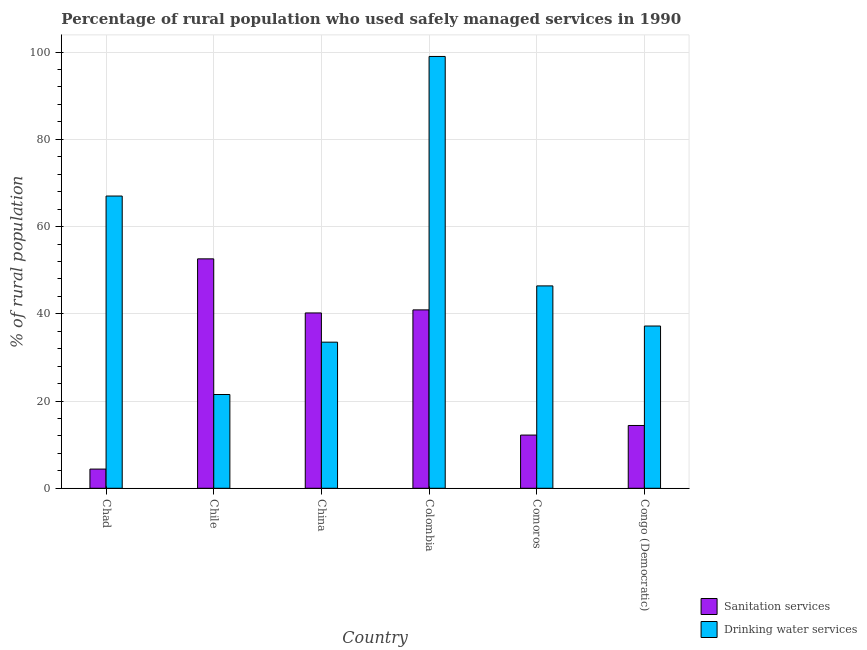How many bars are there on the 5th tick from the left?
Your response must be concise. 2. What is the label of the 2nd group of bars from the left?
Keep it short and to the point. Chile. What is the percentage of rural population who used drinking water services in Comoros?
Make the answer very short. 46.4. Across all countries, what is the maximum percentage of rural population who used sanitation services?
Your answer should be compact. 52.6. Across all countries, what is the minimum percentage of rural population who used sanitation services?
Offer a terse response. 4.4. In which country was the percentage of rural population who used sanitation services minimum?
Keep it short and to the point. Chad. What is the total percentage of rural population who used sanitation services in the graph?
Keep it short and to the point. 164.7. What is the difference between the percentage of rural population who used sanitation services in Chile and that in Congo (Democratic)?
Your answer should be very brief. 38.2. What is the difference between the percentage of rural population who used sanitation services in Chad and the percentage of rural population who used drinking water services in Chile?
Make the answer very short. -17.1. What is the average percentage of rural population who used sanitation services per country?
Make the answer very short. 27.45. What is the difference between the percentage of rural population who used sanitation services and percentage of rural population who used drinking water services in Congo (Democratic)?
Your answer should be compact. -22.8. In how many countries, is the percentage of rural population who used sanitation services greater than 12 %?
Your response must be concise. 5. What is the ratio of the percentage of rural population who used drinking water services in Chad to that in Colombia?
Provide a succinct answer. 0.68. Is the percentage of rural population who used sanitation services in China less than that in Congo (Democratic)?
Provide a short and direct response. No. Is the difference between the percentage of rural population who used drinking water services in Chad and Comoros greater than the difference between the percentage of rural population who used sanitation services in Chad and Comoros?
Offer a terse response. Yes. What is the difference between the highest and the second highest percentage of rural population who used drinking water services?
Offer a terse response. 32. What is the difference between the highest and the lowest percentage of rural population who used drinking water services?
Provide a succinct answer. 77.5. Is the sum of the percentage of rural population who used sanitation services in Chile and Colombia greater than the maximum percentage of rural population who used drinking water services across all countries?
Make the answer very short. No. What does the 2nd bar from the left in Colombia represents?
Keep it short and to the point. Drinking water services. What does the 1st bar from the right in Chile represents?
Offer a terse response. Drinking water services. Are all the bars in the graph horizontal?
Offer a very short reply. No. Does the graph contain any zero values?
Offer a very short reply. No. Where does the legend appear in the graph?
Offer a very short reply. Bottom right. What is the title of the graph?
Your response must be concise. Percentage of rural population who used safely managed services in 1990. What is the label or title of the X-axis?
Provide a succinct answer. Country. What is the label or title of the Y-axis?
Offer a very short reply. % of rural population. What is the % of rural population of Sanitation services in Chad?
Offer a terse response. 4.4. What is the % of rural population in Drinking water services in Chad?
Ensure brevity in your answer.  67. What is the % of rural population in Sanitation services in Chile?
Ensure brevity in your answer.  52.6. What is the % of rural population of Sanitation services in China?
Your answer should be very brief. 40.2. What is the % of rural population in Drinking water services in China?
Make the answer very short. 33.5. What is the % of rural population of Sanitation services in Colombia?
Ensure brevity in your answer.  40.9. What is the % of rural population in Sanitation services in Comoros?
Give a very brief answer. 12.2. What is the % of rural population in Drinking water services in Comoros?
Offer a very short reply. 46.4. What is the % of rural population of Drinking water services in Congo (Democratic)?
Your response must be concise. 37.2. Across all countries, what is the maximum % of rural population of Sanitation services?
Provide a succinct answer. 52.6. Across all countries, what is the minimum % of rural population in Sanitation services?
Your answer should be compact. 4.4. What is the total % of rural population of Sanitation services in the graph?
Ensure brevity in your answer.  164.7. What is the total % of rural population in Drinking water services in the graph?
Offer a very short reply. 304.6. What is the difference between the % of rural population of Sanitation services in Chad and that in Chile?
Provide a succinct answer. -48.2. What is the difference between the % of rural population in Drinking water services in Chad and that in Chile?
Offer a terse response. 45.5. What is the difference between the % of rural population of Sanitation services in Chad and that in China?
Keep it short and to the point. -35.8. What is the difference between the % of rural population of Drinking water services in Chad and that in China?
Make the answer very short. 33.5. What is the difference between the % of rural population of Sanitation services in Chad and that in Colombia?
Your response must be concise. -36.5. What is the difference between the % of rural population of Drinking water services in Chad and that in Colombia?
Keep it short and to the point. -32. What is the difference between the % of rural population of Sanitation services in Chad and that in Comoros?
Provide a succinct answer. -7.8. What is the difference between the % of rural population of Drinking water services in Chad and that in Comoros?
Your answer should be compact. 20.6. What is the difference between the % of rural population in Sanitation services in Chad and that in Congo (Democratic)?
Provide a short and direct response. -10. What is the difference between the % of rural population of Drinking water services in Chad and that in Congo (Democratic)?
Your answer should be compact. 29.8. What is the difference between the % of rural population of Sanitation services in Chile and that in China?
Make the answer very short. 12.4. What is the difference between the % of rural population of Drinking water services in Chile and that in Colombia?
Your answer should be compact. -77.5. What is the difference between the % of rural population in Sanitation services in Chile and that in Comoros?
Offer a terse response. 40.4. What is the difference between the % of rural population in Drinking water services in Chile and that in Comoros?
Offer a very short reply. -24.9. What is the difference between the % of rural population in Sanitation services in Chile and that in Congo (Democratic)?
Make the answer very short. 38.2. What is the difference between the % of rural population in Drinking water services in Chile and that in Congo (Democratic)?
Make the answer very short. -15.7. What is the difference between the % of rural population in Sanitation services in China and that in Colombia?
Provide a short and direct response. -0.7. What is the difference between the % of rural population in Drinking water services in China and that in Colombia?
Your answer should be compact. -65.5. What is the difference between the % of rural population in Sanitation services in China and that in Congo (Democratic)?
Offer a terse response. 25.8. What is the difference between the % of rural population in Drinking water services in China and that in Congo (Democratic)?
Make the answer very short. -3.7. What is the difference between the % of rural population in Sanitation services in Colombia and that in Comoros?
Offer a very short reply. 28.7. What is the difference between the % of rural population of Drinking water services in Colombia and that in Comoros?
Your answer should be compact. 52.6. What is the difference between the % of rural population in Drinking water services in Colombia and that in Congo (Democratic)?
Your response must be concise. 61.8. What is the difference between the % of rural population in Sanitation services in Comoros and that in Congo (Democratic)?
Your answer should be very brief. -2.2. What is the difference between the % of rural population of Sanitation services in Chad and the % of rural population of Drinking water services in Chile?
Provide a succinct answer. -17.1. What is the difference between the % of rural population of Sanitation services in Chad and the % of rural population of Drinking water services in China?
Your answer should be very brief. -29.1. What is the difference between the % of rural population in Sanitation services in Chad and the % of rural population in Drinking water services in Colombia?
Make the answer very short. -94.6. What is the difference between the % of rural population of Sanitation services in Chad and the % of rural population of Drinking water services in Comoros?
Provide a short and direct response. -42. What is the difference between the % of rural population in Sanitation services in Chad and the % of rural population in Drinking water services in Congo (Democratic)?
Provide a succinct answer. -32.8. What is the difference between the % of rural population in Sanitation services in Chile and the % of rural population in Drinking water services in China?
Your response must be concise. 19.1. What is the difference between the % of rural population of Sanitation services in Chile and the % of rural population of Drinking water services in Colombia?
Give a very brief answer. -46.4. What is the difference between the % of rural population in Sanitation services in China and the % of rural population in Drinking water services in Colombia?
Provide a short and direct response. -58.8. What is the difference between the % of rural population of Sanitation services in China and the % of rural population of Drinking water services in Congo (Democratic)?
Your answer should be very brief. 3. What is the difference between the % of rural population of Sanitation services in Comoros and the % of rural population of Drinking water services in Congo (Democratic)?
Your answer should be compact. -25. What is the average % of rural population in Sanitation services per country?
Your response must be concise. 27.45. What is the average % of rural population in Drinking water services per country?
Your response must be concise. 50.77. What is the difference between the % of rural population in Sanitation services and % of rural population in Drinking water services in Chad?
Your response must be concise. -62.6. What is the difference between the % of rural population in Sanitation services and % of rural population in Drinking water services in Chile?
Your answer should be compact. 31.1. What is the difference between the % of rural population of Sanitation services and % of rural population of Drinking water services in China?
Your answer should be very brief. 6.7. What is the difference between the % of rural population in Sanitation services and % of rural population in Drinking water services in Colombia?
Your answer should be very brief. -58.1. What is the difference between the % of rural population of Sanitation services and % of rural population of Drinking water services in Comoros?
Give a very brief answer. -34.2. What is the difference between the % of rural population of Sanitation services and % of rural population of Drinking water services in Congo (Democratic)?
Provide a short and direct response. -22.8. What is the ratio of the % of rural population of Sanitation services in Chad to that in Chile?
Give a very brief answer. 0.08. What is the ratio of the % of rural population in Drinking water services in Chad to that in Chile?
Offer a very short reply. 3.12. What is the ratio of the % of rural population in Sanitation services in Chad to that in China?
Offer a terse response. 0.11. What is the ratio of the % of rural population in Drinking water services in Chad to that in China?
Offer a terse response. 2. What is the ratio of the % of rural population of Sanitation services in Chad to that in Colombia?
Give a very brief answer. 0.11. What is the ratio of the % of rural population in Drinking water services in Chad to that in Colombia?
Provide a succinct answer. 0.68. What is the ratio of the % of rural population in Sanitation services in Chad to that in Comoros?
Your response must be concise. 0.36. What is the ratio of the % of rural population in Drinking water services in Chad to that in Comoros?
Give a very brief answer. 1.44. What is the ratio of the % of rural population of Sanitation services in Chad to that in Congo (Democratic)?
Offer a terse response. 0.31. What is the ratio of the % of rural population in Drinking water services in Chad to that in Congo (Democratic)?
Your response must be concise. 1.8. What is the ratio of the % of rural population in Sanitation services in Chile to that in China?
Your answer should be compact. 1.31. What is the ratio of the % of rural population in Drinking water services in Chile to that in China?
Provide a short and direct response. 0.64. What is the ratio of the % of rural population in Sanitation services in Chile to that in Colombia?
Your answer should be compact. 1.29. What is the ratio of the % of rural population in Drinking water services in Chile to that in Colombia?
Give a very brief answer. 0.22. What is the ratio of the % of rural population in Sanitation services in Chile to that in Comoros?
Keep it short and to the point. 4.31. What is the ratio of the % of rural population in Drinking water services in Chile to that in Comoros?
Keep it short and to the point. 0.46. What is the ratio of the % of rural population of Sanitation services in Chile to that in Congo (Democratic)?
Provide a short and direct response. 3.65. What is the ratio of the % of rural population of Drinking water services in Chile to that in Congo (Democratic)?
Make the answer very short. 0.58. What is the ratio of the % of rural population of Sanitation services in China to that in Colombia?
Offer a very short reply. 0.98. What is the ratio of the % of rural population in Drinking water services in China to that in Colombia?
Your answer should be very brief. 0.34. What is the ratio of the % of rural population in Sanitation services in China to that in Comoros?
Make the answer very short. 3.3. What is the ratio of the % of rural population of Drinking water services in China to that in Comoros?
Keep it short and to the point. 0.72. What is the ratio of the % of rural population in Sanitation services in China to that in Congo (Democratic)?
Keep it short and to the point. 2.79. What is the ratio of the % of rural population in Drinking water services in China to that in Congo (Democratic)?
Make the answer very short. 0.9. What is the ratio of the % of rural population in Sanitation services in Colombia to that in Comoros?
Provide a succinct answer. 3.35. What is the ratio of the % of rural population of Drinking water services in Colombia to that in Comoros?
Your response must be concise. 2.13. What is the ratio of the % of rural population of Sanitation services in Colombia to that in Congo (Democratic)?
Provide a short and direct response. 2.84. What is the ratio of the % of rural population of Drinking water services in Colombia to that in Congo (Democratic)?
Your answer should be very brief. 2.66. What is the ratio of the % of rural population in Sanitation services in Comoros to that in Congo (Democratic)?
Give a very brief answer. 0.85. What is the ratio of the % of rural population in Drinking water services in Comoros to that in Congo (Democratic)?
Your answer should be compact. 1.25. What is the difference between the highest and the lowest % of rural population of Sanitation services?
Give a very brief answer. 48.2. What is the difference between the highest and the lowest % of rural population of Drinking water services?
Your answer should be compact. 77.5. 